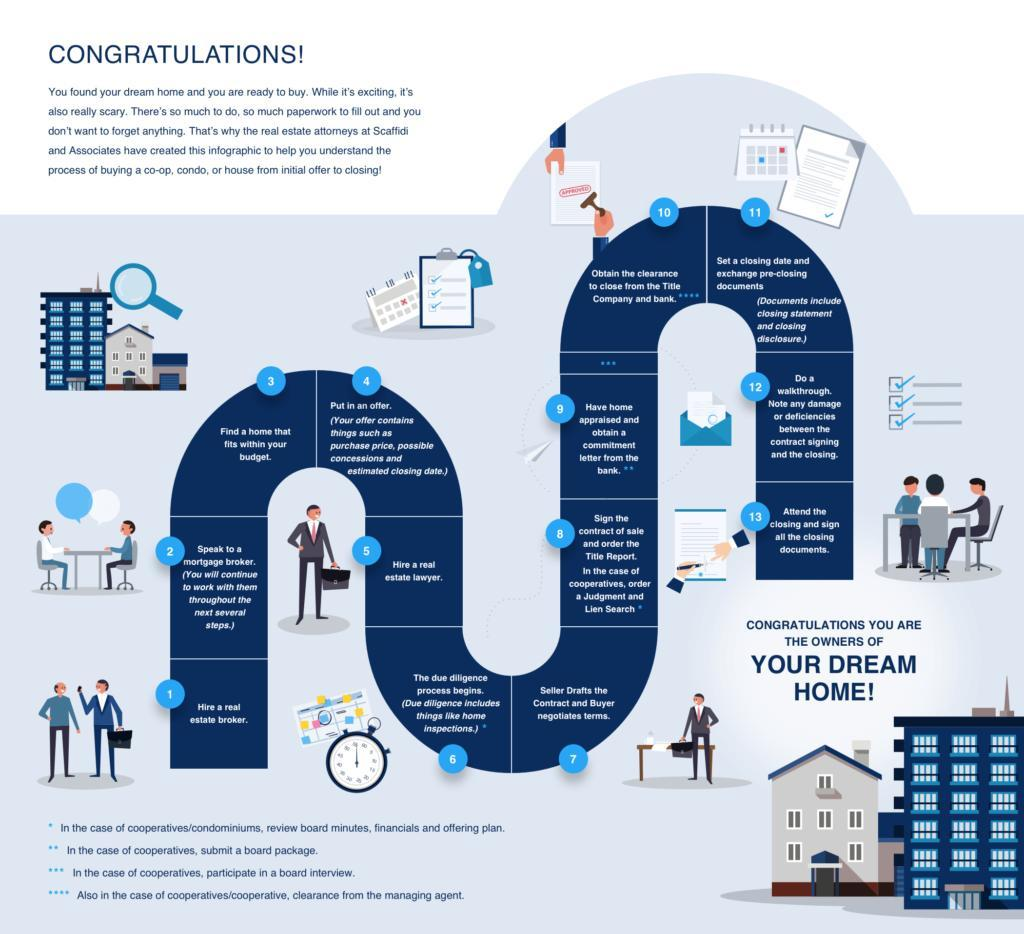Which is the step before one finally owns a home?
Answer the question with a short phrase. 13 Which step does the real estate lawyer come to initially survey the home to sold? 6 